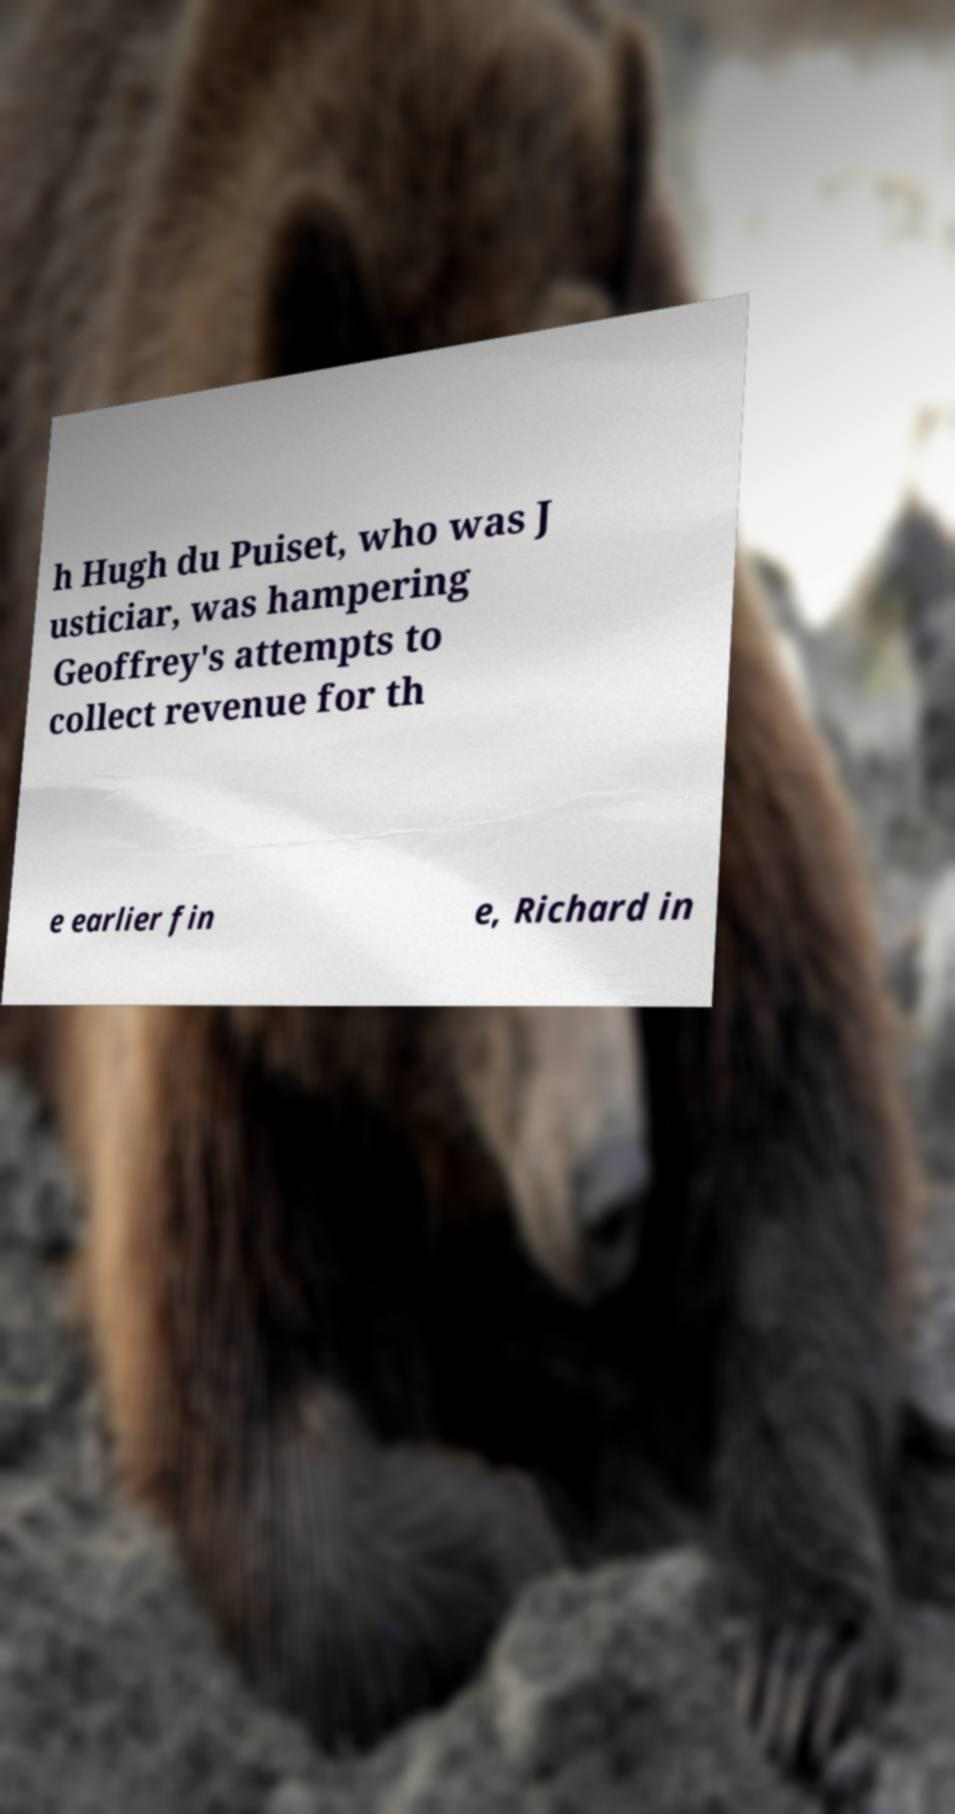What messages or text are displayed in this image? I need them in a readable, typed format. h Hugh du Puiset, who was J usticiar, was hampering Geoffrey's attempts to collect revenue for th e earlier fin e, Richard in 